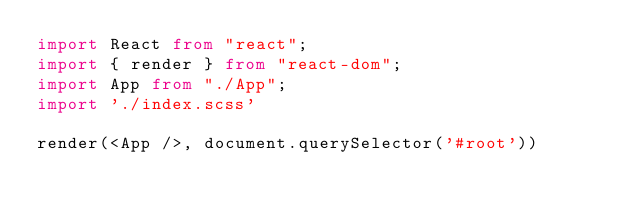<code> <loc_0><loc_0><loc_500><loc_500><_TypeScript_>import React from "react";
import { render } from "react-dom";
import App from "./App";
import './index.scss'

render(<App />, document.querySelector('#root'))</code> 